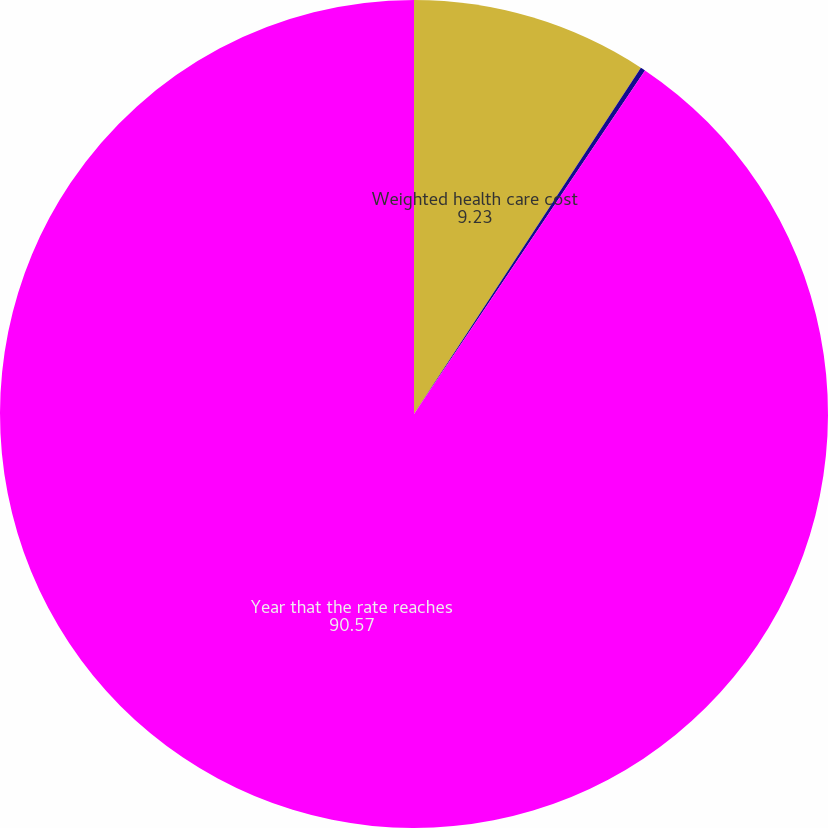Convert chart. <chart><loc_0><loc_0><loc_500><loc_500><pie_chart><fcel>Weighted health care cost<fcel>Rate to which cost trend rate<fcel>Year that the rate reaches<nl><fcel>9.23%<fcel>0.19%<fcel>90.57%<nl></chart> 